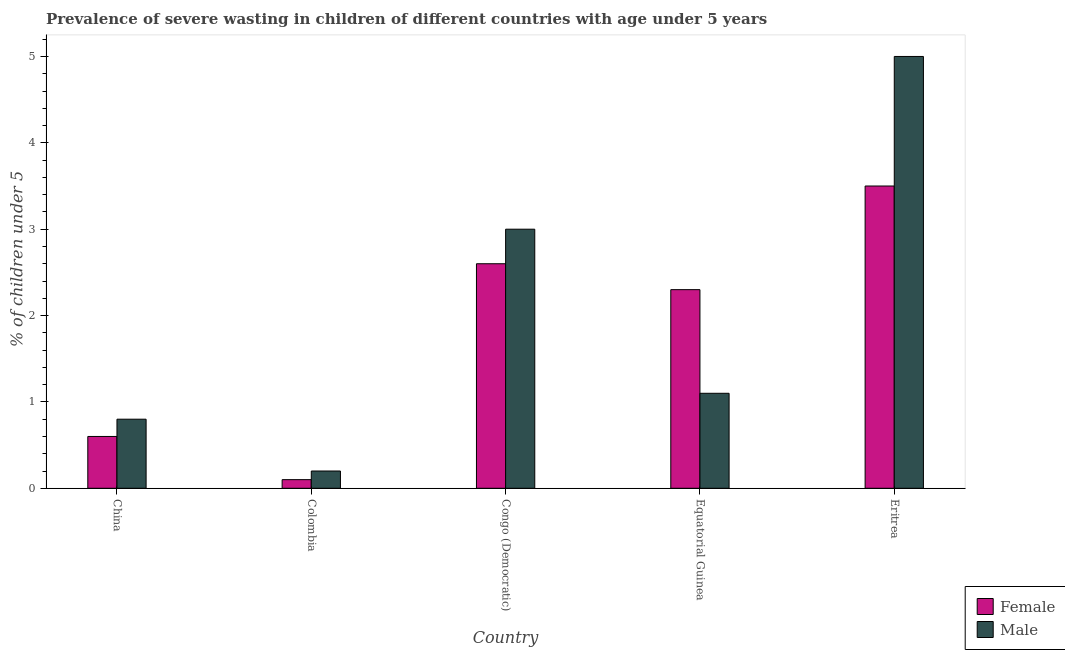How many different coloured bars are there?
Provide a succinct answer. 2. Are the number of bars per tick equal to the number of legend labels?
Make the answer very short. Yes. Are the number of bars on each tick of the X-axis equal?
Make the answer very short. Yes. How many bars are there on the 5th tick from the left?
Offer a terse response. 2. What is the percentage of undernourished female children in Congo (Democratic)?
Give a very brief answer. 2.6. Across all countries, what is the minimum percentage of undernourished female children?
Keep it short and to the point. 0.1. In which country was the percentage of undernourished male children maximum?
Offer a very short reply. Eritrea. What is the total percentage of undernourished male children in the graph?
Provide a short and direct response. 10.1. What is the difference between the percentage of undernourished male children in China and that in Equatorial Guinea?
Offer a terse response. -0.3. What is the difference between the percentage of undernourished female children in Congo (Democratic) and the percentage of undernourished male children in Eritrea?
Make the answer very short. -2.4. What is the average percentage of undernourished male children per country?
Provide a short and direct response. 2.02. What is the difference between the percentage of undernourished female children and percentage of undernourished male children in Eritrea?
Provide a succinct answer. -1.5. In how many countries, is the percentage of undernourished male children greater than 1.4 %?
Provide a short and direct response. 2. What is the ratio of the percentage of undernourished male children in China to that in Eritrea?
Give a very brief answer. 0.16. Is the percentage of undernourished male children in China less than that in Equatorial Guinea?
Provide a succinct answer. Yes. Is the difference between the percentage of undernourished male children in China and Colombia greater than the difference between the percentage of undernourished female children in China and Colombia?
Your answer should be very brief. Yes. What is the difference between the highest and the second highest percentage of undernourished male children?
Give a very brief answer. 2. What is the difference between the highest and the lowest percentage of undernourished male children?
Ensure brevity in your answer.  4.8. What does the 2nd bar from the left in Eritrea represents?
Provide a short and direct response. Male. What does the 1st bar from the right in Eritrea represents?
Your answer should be compact. Male. How many countries are there in the graph?
Keep it short and to the point. 5. What is the difference between two consecutive major ticks on the Y-axis?
Make the answer very short. 1. Are the values on the major ticks of Y-axis written in scientific E-notation?
Your answer should be very brief. No. Does the graph contain grids?
Your response must be concise. No. How many legend labels are there?
Ensure brevity in your answer.  2. What is the title of the graph?
Make the answer very short. Prevalence of severe wasting in children of different countries with age under 5 years. Does "Electricity and heat production" appear as one of the legend labels in the graph?
Make the answer very short. No. What is the label or title of the X-axis?
Keep it short and to the point. Country. What is the label or title of the Y-axis?
Your response must be concise.  % of children under 5. What is the  % of children under 5 of Female in China?
Provide a succinct answer. 0.6. What is the  % of children under 5 of Male in China?
Make the answer very short. 0.8. What is the  % of children under 5 in Female in Colombia?
Your answer should be compact. 0.1. What is the  % of children under 5 in Male in Colombia?
Give a very brief answer. 0.2. What is the  % of children under 5 of Female in Congo (Democratic)?
Your answer should be compact. 2.6. What is the  % of children under 5 in Male in Congo (Democratic)?
Provide a succinct answer. 3. What is the  % of children under 5 in Female in Equatorial Guinea?
Your answer should be very brief. 2.3. What is the  % of children under 5 of Male in Equatorial Guinea?
Your answer should be very brief. 1.1. What is the  % of children under 5 in Female in Eritrea?
Make the answer very short. 3.5. What is the  % of children under 5 of Male in Eritrea?
Offer a terse response. 5. Across all countries, what is the minimum  % of children under 5 of Female?
Ensure brevity in your answer.  0.1. Across all countries, what is the minimum  % of children under 5 of Male?
Give a very brief answer. 0.2. What is the total  % of children under 5 of Male in the graph?
Your answer should be compact. 10.1. What is the difference between the  % of children under 5 in Female in China and that in Colombia?
Your answer should be very brief. 0.5. What is the difference between the  % of children under 5 in Male in China and that in Colombia?
Your answer should be compact. 0.6. What is the difference between the  % of children under 5 of Female in China and that in Congo (Democratic)?
Ensure brevity in your answer.  -2. What is the difference between the  % of children under 5 of Male in China and that in Congo (Democratic)?
Ensure brevity in your answer.  -2.2. What is the difference between the  % of children under 5 of Female in China and that in Eritrea?
Make the answer very short. -2.9. What is the difference between the  % of children under 5 in Male in China and that in Eritrea?
Ensure brevity in your answer.  -4.2. What is the difference between the  % of children under 5 of Female in Colombia and that in Congo (Democratic)?
Make the answer very short. -2.5. What is the difference between the  % of children under 5 of Male in Colombia and that in Congo (Democratic)?
Your response must be concise. -2.8. What is the difference between the  % of children under 5 in Female in Congo (Democratic) and that in Equatorial Guinea?
Offer a very short reply. 0.3. What is the difference between the  % of children under 5 in Male in Congo (Democratic) and that in Eritrea?
Make the answer very short. -2. What is the difference between the  % of children under 5 in Female in China and the  % of children under 5 in Male in Congo (Democratic)?
Offer a very short reply. -2.4. What is the difference between the  % of children under 5 of Female in China and the  % of children under 5 of Male in Equatorial Guinea?
Provide a short and direct response. -0.5. What is the difference between the  % of children under 5 in Female in Colombia and the  % of children under 5 in Male in Congo (Democratic)?
Make the answer very short. -2.9. What is the difference between the  % of children under 5 of Female in Colombia and the  % of children under 5 of Male in Equatorial Guinea?
Offer a terse response. -1. What is the difference between the  % of children under 5 in Female in Colombia and the  % of children under 5 in Male in Eritrea?
Your answer should be compact. -4.9. What is the difference between the  % of children under 5 of Female in Congo (Democratic) and the  % of children under 5 of Male in Eritrea?
Provide a succinct answer. -2.4. What is the average  % of children under 5 of Female per country?
Your answer should be very brief. 1.82. What is the average  % of children under 5 in Male per country?
Provide a succinct answer. 2.02. What is the difference between the  % of children under 5 in Female and  % of children under 5 in Male in China?
Your answer should be very brief. -0.2. What is the difference between the  % of children under 5 in Female and  % of children under 5 in Male in Colombia?
Give a very brief answer. -0.1. What is the difference between the  % of children under 5 in Female and  % of children under 5 in Male in Congo (Democratic)?
Give a very brief answer. -0.4. What is the difference between the  % of children under 5 of Female and  % of children under 5 of Male in Equatorial Guinea?
Keep it short and to the point. 1.2. What is the difference between the  % of children under 5 of Female and  % of children under 5 of Male in Eritrea?
Your answer should be very brief. -1.5. What is the ratio of the  % of children under 5 in Female in China to that in Congo (Democratic)?
Ensure brevity in your answer.  0.23. What is the ratio of the  % of children under 5 of Male in China to that in Congo (Democratic)?
Offer a very short reply. 0.27. What is the ratio of the  % of children under 5 of Female in China to that in Equatorial Guinea?
Ensure brevity in your answer.  0.26. What is the ratio of the  % of children under 5 in Male in China to that in Equatorial Guinea?
Provide a short and direct response. 0.73. What is the ratio of the  % of children under 5 in Female in China to that in Eritrea?
Offer a very short reply. 0.17. What is the ratio of the  % of children under 5 of Male in China to that in Eritrea?
Provide a succinct answer. 0.16. What is the ratio of the  % of children under 5 of Female in Colombia to that in Congo (Democratic)?
Give a very brief answer. 0.04. What is the ratio of the  % of children under 5 in Male in Colombia to that in Congo (Democratic)?
Give a very brief answer. 0.07. What is the ratio of the  % of children under 5 in Female in Colombia to that in Equatorial Guinea?
Keep it short and to the point. 0.04. What is the ratio of the  % of children under 5 in Male in Colombia to that in Equatorial Guinea?
Give a very brief answer. 0.18. What is the ratio of the  % of children under 5 of Female in Colombia to that in Eritrea?
Offer a very short reply. 0.03. What is the ratio of the  % of children under 5 in Female in Congo (Democratic) to that in Equatorial Guinea?
Give a very brief answer. 1.13. What is the ratio of the  % of children under 5 in Male in Congo (Democratic) to that in Equatorial Guinea?
Provide a succinct answer. 2.73. What is the ratio of the  % of children under 5 in Female in Congo (Democratic) to that in Eritrea?
Keep it short and to the point. 0.74. What is the ratio of the  % of children under 5 in Male in Congo (Democratic) to that in Eritrea?
Offer a terse response. 0.6. What is the ratio of the  % of children under 5 in Female in Equatorial Guinea to that in Eritrea?
Your response must be concise. 0.66. What is the ratio of the  % of children under 5 of Male in Equatorial Guinea to that in Eritrea?
Your response must be concise. 0.22. What is the difference between the highest and the lowest  % of children under 5 of Female?
Provide a succinct answer. 3.4. 